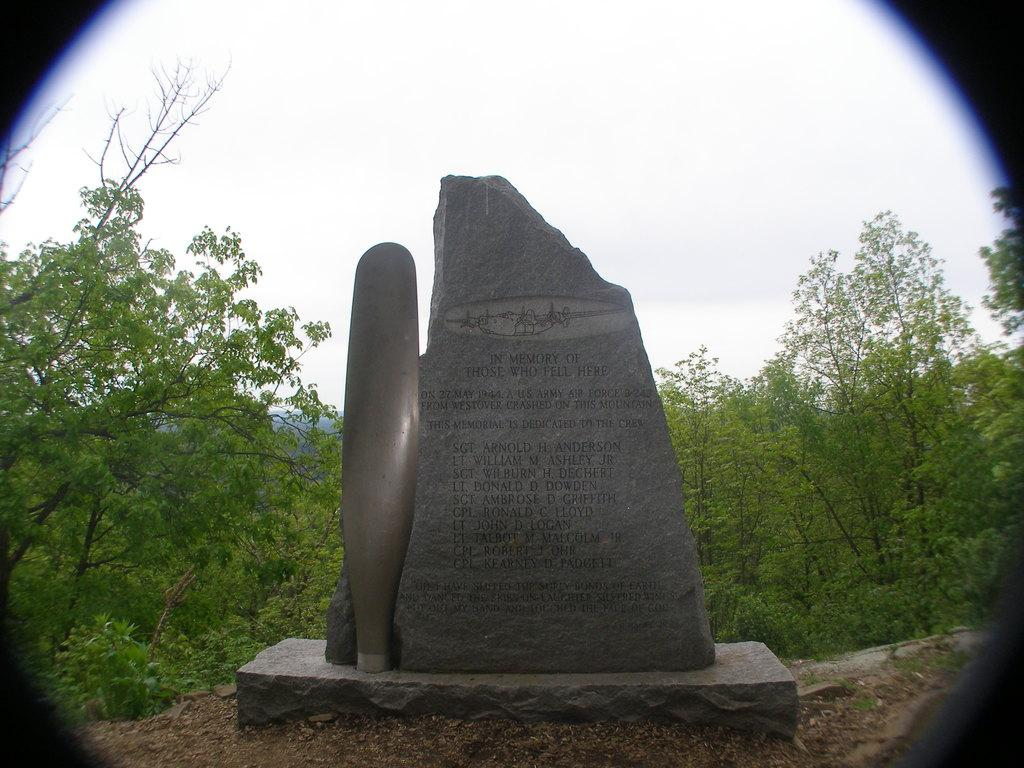What is the main object in the image? There is a stone in the image. What can be seen in the background of the image? There are trees and the sky visible in the background of the image. What color is the orange in the image? There is no orange present in the image; it features a stone and background elements of trees and sky. 